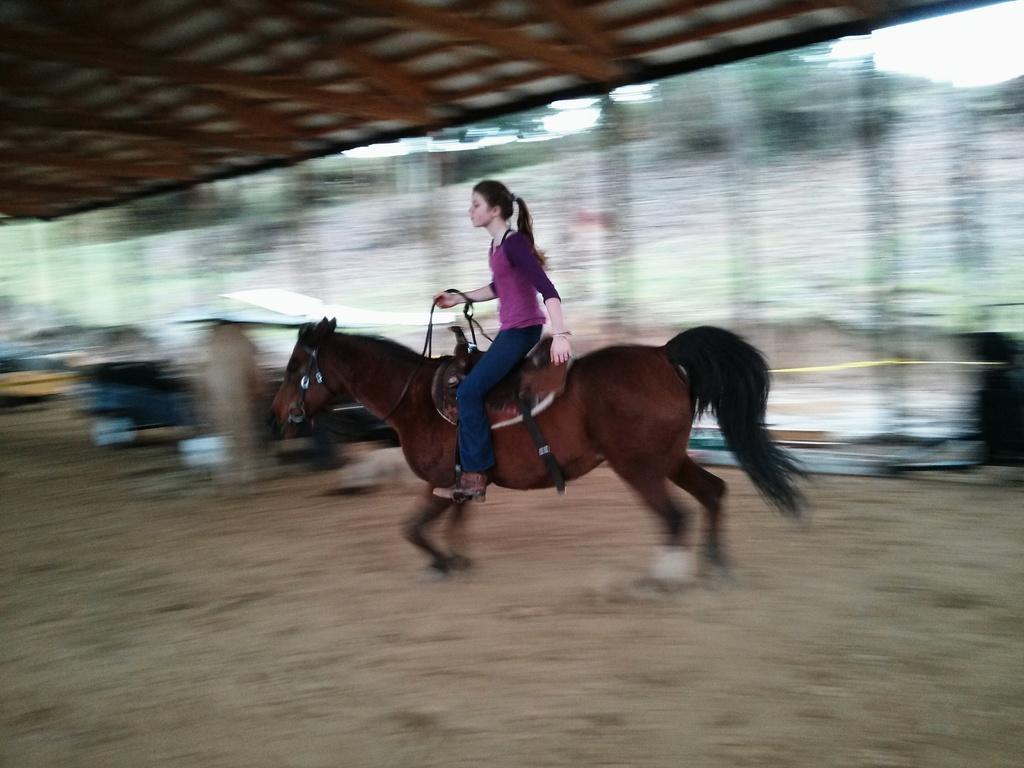Could you give a brief overview of what you see in this image? In this image there is a horse running, there is a woman sitting on the horse, there is the sky towards the top of the image, there are trees, there is the roof towards the top of the image, there are objects on the ground, the bottom of the image is blurred. 